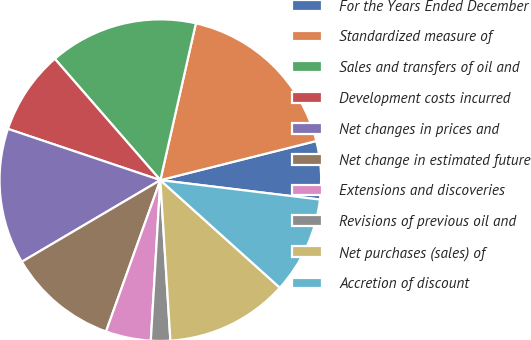Convert chart to OTSL. <chart><loc_0><loc_0><loc_500><loc_500><pie_chart><fcel>For the Years Ended December<fcel>Standardized measure of<fcel>Sales and transfers of oil and<fcel>Development costs incurred<fcel>Net changes in prices and<fcel>Net change in estimated future<fcel>Extensions and discoveries<fcel>Revisions of previous oil and<fcel>Net purchases (sales) of<fcel>Accretion of discount<nl><fcel>5.84%<fcel>17.54%<fcel>14.94%<fcel>8.44%<fcel>13.64%<fcel>11.04%<fcel>4.54%<fcel>1.94%<fcel>12.34%<fcel>9.74%<nl></chart> 